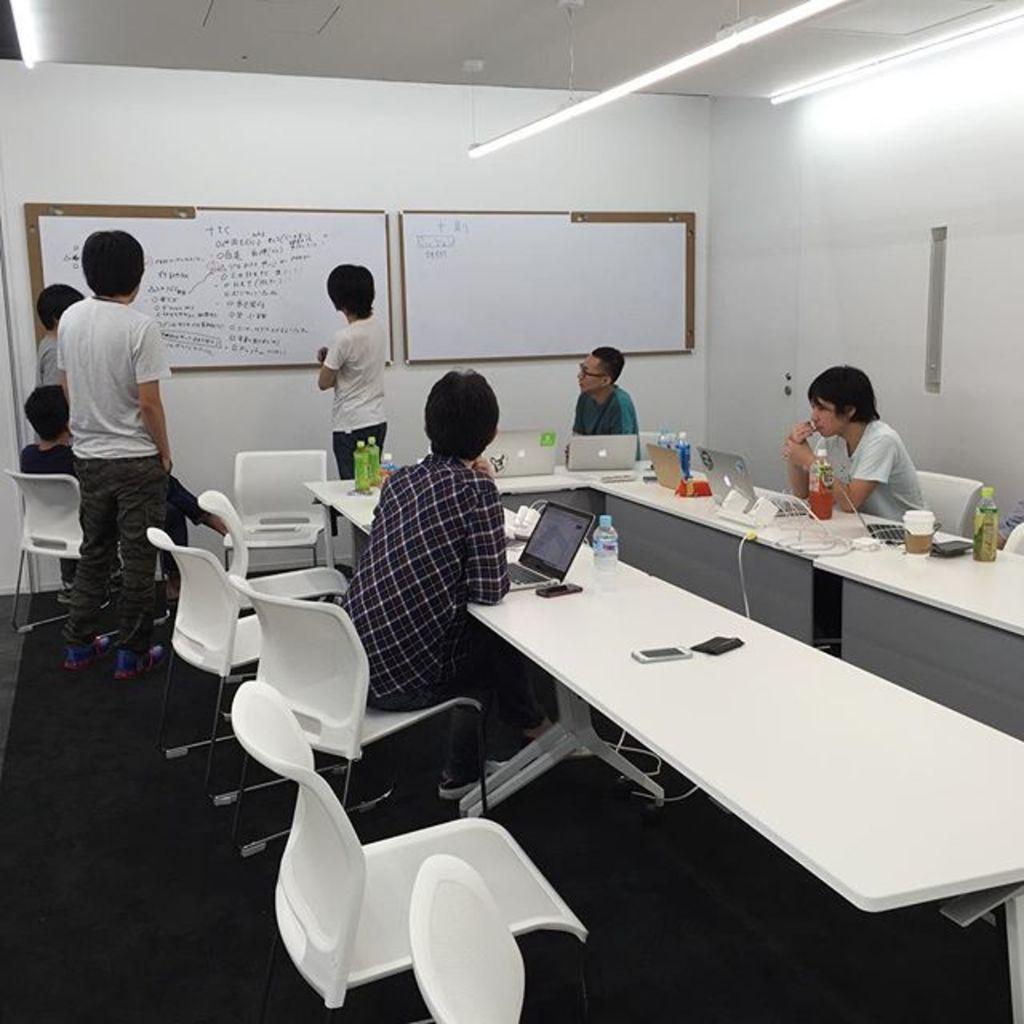Please provide a concise description of this image. The image looks like a room in which there are few students who are looking at the white board which is in front of them. Some students are sitting on the chair which is in front of the table. On the table there are mobiles,laptops,bottles,cups,routers on it. At the top there are lights. 